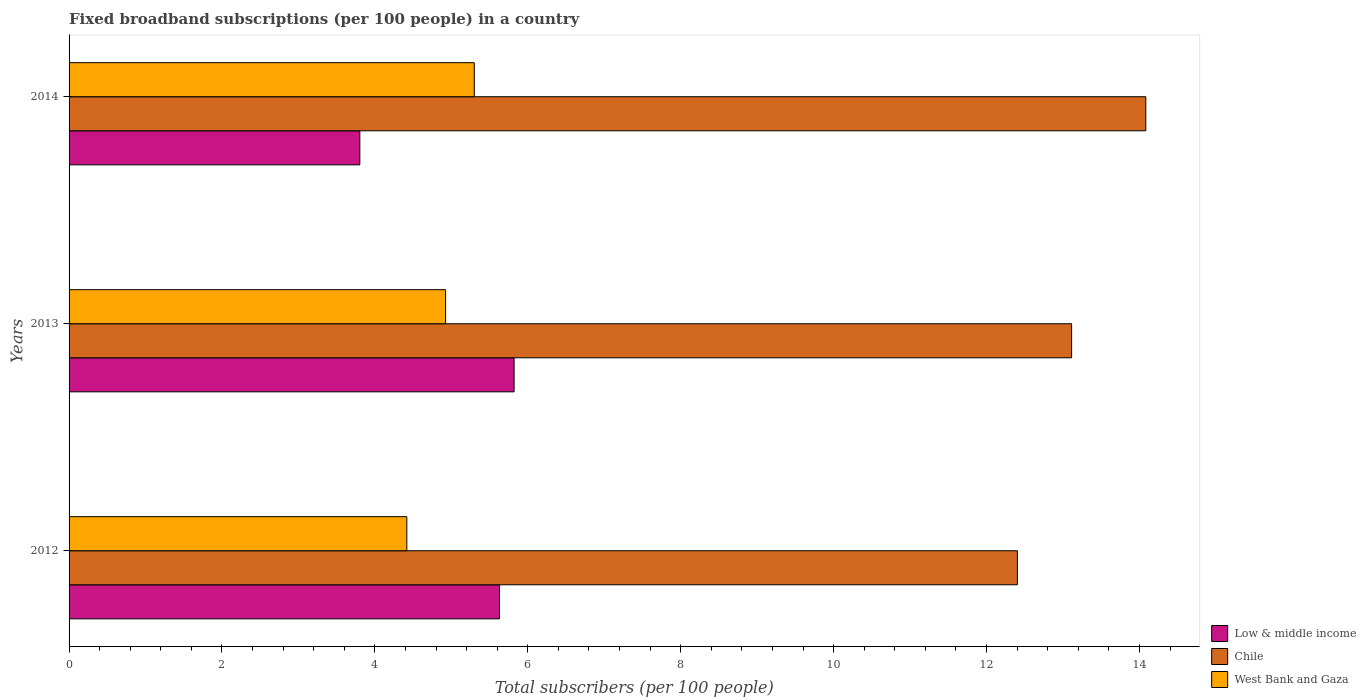How many different coloured bars are there?
Ensure brevity in your answer.  3. How many groups of bars are there?
Keep it short and to the point. 3. Are the number of bars per tick equal to the number of legend labels?
Ensure brevity in your answer.  Yes. How many bars are there on the 1st tick from the top?
Provide a short and direct response. 3. How many bars are there on the 2nd tick from the bottom?
Keep it short and to the point. 3. What is the label of the 1st group of bars from the top?
Your answer should be very brief. 2014. In how many cases, is the number of bars for a given year not equal to the number of legend labels?
Keep it short and to the point. 0. What is the number of broadband subscriptions in Chile in 2012?
Ensure brevity in your answer.  12.4. Across all years, what is the maximum number of broadband subscriptions in Chile?
Provide a short and direct response. 14.08. Across all years, what is the minimum number of broadband subscriptions in Low & middle income?
Ensure brevity in your answer.  3.8. In which year was the number of broadband subscriptions in West Bank and Gaza minimum?
Make the answer very short. 2012. What is the total number of broadband subscriptions in Low & middle income in the graph?
Offer a very short reply. 15.25. What is the difference between the number of broadband subscriptions in Low & middle income in 2012 and that in 2013?
Give a very brief answer. -0.19. What is the difference between the number of broadband subscriptions in Low & middle income in 2014 and the number of broadband subscriptions in Chile in 2013?
Offer a terse response. -9.31. What is the average number of broadband subscriptions in Chile per year?
Offer a terse response. 13.2. In the year 2012, what is the difference between the number of broadband subscriptions in Chile and number of broadband subscriptions in West Bank and Gaza?
Your response must be concise. 7.99. What is the ratio of the number of broadband subscriptions in Low & middle income in 2013 to that in 2014?
Offer a very short reply. 1.53. Is the difference between the number of broadband subscriptions in Chile in 2012 and 2013 greater than the difference between the number of broadband subscriptions in West Bank and Gaza in 2012 and 2013?
Provide a succinct answer. No. What is the difference between the highest and the second highest number of broadband subscriptions in Chile?
Provide a succinct answer. 0.97. What is the difference between the highest and the lowest number of broadband subscriptions in Low & middle income?
Your response must be concise. 2.02. In how many years, is the number of broadband subscriptions in Chile greater than the average number of broadband subscriptions in Chile taken over all years?
Offer a terse response. 1. What does the 2nd bar from the top in 2012 represents?
Your answer should be compact. Chile. What does the 1st bar from the bottom in 2013 represents?
Keep it short and to the point. Low & middle income. What is the difference between two consecutive major ticks on the X-axis?
Make the answer very short. 2. Does the graph contain grids?
Give a very brief answer. No. Where does the legend appear in the graph?
Your response must be concise. Bottom right. How many legend labels are there?
Keep it short and to the point. 3. How are the legend labels stacked?
Your answer should be compact. Vertical. What is the title of the graph?
Keep it short and to the point. Fixed broadband subscriptions (per 100 people) in a country. Does "Upper middle income" appear as one of the legend labels in the graph?
Provide a succinct answer. No. What is the label or title of the X-axis?
Provide a short and direct response. Total subscribers (per 100 people). What is the label or title of the Y-axis?
Offer a very short reply. Years. What is the Total subscribers (per 100 people) in Low & middle income in 2012?
Your answer should be very brief. 5.63. What is the Total subscribers (per 100 people) of Chile in 2012?
Keep it short and to the point. 12.4. What is the Total subscribers (per 100 people) in West Bank and Gaza in 2012?
Offer a terse response. 4.42. What is the Total subscribers (per 100 people) of Low & middle income in 2013?
Provide a short and direct response. 5.82. What is the Total subscribers (per 100 people) in Chile in 2013?
Provide a short and direct response. 13.11. What is the Total subscribers (per 100 people) of West Bank and Gaza in 2013?
Your response must be concise. 4.92. What is the Total subscribers (per 100 people) in Low & middle income in 2014?
Make the answer very short. 3.8. What is the Total subscribers (per 100 people) in Chile in 2014?
Provide a succinct answer. 14.08. What is the Total subscribers (per 100 people) of West Bank and Gaza in 2014?
Give a very brief answer. 5.3. Across all years, what is the maximum Total subscribers (per 100 people) in Low & middle income?
Offer a terse response. 5.82. Across all years, what is the maximum Total subscribers (per 100 people) in Chile?
Offer a very short reply. 14.08. Across all years, what is the maximum Total subscribers (per 100 people) of West Bank and Gaza?
Your answer should be compact. 5.3. Across all years, what is the minimum Total subscribers (per 100 people) in Low & middle income?
Ensure brevity in your answer.  3.8. Across all years, what is the minimum Total subscribers (per 100 people) in Chile?
Provide a short and direct response. 12.4. Across all years, what is the minimum Total subscribers (per 100 people) in West Bank and Gaza?
Your answer should be compact. 4.42. What is the total Total subscribers (per 100 people) of Low & middle income in the graph?
Your response must be concise. 15.25. What is the total Total subscribers (per 100 people) in Chile in the graph?
Offer a terse response. 39.6. What is the total Total subscribers (per 100 people) of West Bank and Gaza in the graph?
Keep it short and to the point. 14.64. What is the difference between the Total subscribers (per 100 people) in Low & middle income in 2012 and that in 2013?
Provide a short and direct response. -0.19. What is the difference between the Total subscribers (per 100 people) in Chile in 2012 and that in 2013?
Provide a short and direct response. -0.71. What is the difference between the Total subscribers (per 100 people) of West Bank and Gaza in 2012 and that in 2013?
Give a very brief answer. -0.51. What is the difference between the Total subscribers (per 100 people) of Low & middle income in 2012 and that in 2014?
Offer a very short reply. 1.83. What is the difference between the Total subscribers (per 100 people) of Chile in 2012 and that in 2014?
Your response must be concise. -1.68. What is the difference between the Total subscribers (per 100 people) of West Bank and Gaza in 2012 and that in 2014?
Provide a succinct answer. -0.88. What is the difference between the Total subscribers (per 100 people) of Low & middle income in 2013 and that in 2014?
Offer a very short reply. 2.02. What is the difference between the Total subscribers (per 100 people) of Chile in 2013 and that in 2014?
Your answer should be compact. -0.97. What is the difference between the Total subscribers (per 100 people) of West Bank and Gaza in 2013 and that in 2014?
Offer a terse response. -0.38. What is the difference between the Total subscribers (per 100 people) of Low & middle income in 2012 and the Total subscribers (per 100 people) of Chile in 2013?
Ensure brevity in your answer.  -7.48. What is the difference between the Total subscribers (per 100 people) in Low & middle income in 2012 and the Total subscribers (per 100 people) in West Bank and Gaza in 2013?
Your answer should be compact. 0.71. What is the difference between the Total subscribers (per 100 people) of Chile in 2012 and the Total subscribers (per 100 people) of West Bank and Gaza in 2013?
Provide a succinct answer. 7.48. What is the difference between the Total subscribers (per 100 people) in Low & middle income in 2012 and the Total subscribers (per 100 people) in Chile in 2014?
Your answer should be very brief. -8.45. What is the difference between the Total subscribers (per 100 people) of Low & middle income in 2012 and the Total subscribers (per 100 people) of West Bank and Gaza in 2014?
Provide a short and direct response. 0.33. What is the difference between the Total subscribers (per 100 people) in Chile in 2012 and the Total subscribers (per 100 people) in West Bank and Gaza in 2014?
Your answer should be compact. 7.1. What is the difference between the Total subscribers (per 100 people) of Low & middle income in 2013 and the Total subscribers (per 100 people) of Chile in 2014?
Offer a very short reply. -8.26. What is the difference between the Total subscribers (per 100 people) in Low & middle income in 2013 and the Total subscribers (per 100 people) in West Bank and Gaza in 2014?
Offer a terse response. 0.52. What is the difference between the Total subscribers (per 100 people) in Chile in 2013 and the Total subscribers (per 100 people) in West Bank and Gaza in 2014?
Provide a short and direct response. 7.81. What is the average Total subscribers (per 100 people) of Low & middle income per year?
Your response must be concise. 5.08. What is the average Total subscribers (per 100 people) of Chile per year?
Your answer should be compact. 13.2. What is the average Total subscribers (per 100 people) of West Bank and Gaza per year?
Ensure brevity in your answer.  4.88. In the year 2012, what is the difference between the Total subscribers (per 100 people) in Low & middle income and Total subscribers (per 100 people) in Chile?
Your response must be concise. -6.77. In the year 2012, what is the difference between the Total subscribers (per 100 people) of Low & middle income and Total subscribers (per 100 people) of West Bank and Gaza?
Your response must be concise. 1.21. In the year 2012, what is the difference between the Total subscribers (per 100 people) in Chile and Total subscribers (per 100 people) in West Bank and Gaza?
Your answer should be very brief. 7.99. In the year 2013, what is the difference between the Total subscribers (per 100 people) in Low & middle income and Total subscribers (per 100 people) in Chile?
Give a very brief answer. -7.29. In the year 2013, what is the difference between the Total subscribers (per 100 people) in Low & middle income and Total subscribers (per 100 people) in West Bank and Gaza?
Give a very brief answer. 0.9. In the year 2013, what is the difference between the Total subscribers (per 100 people) in Chile and Total subscribers (per 100 people) in West Bank and Gaza?
Ensure brevity in your answer.  8.19. In the year 2014, what is the difference between the Total subscribers (per 100 people) of Low & middle income and Total subscribers (per 100 people) of Chile?
Your response must be concise. -10.28. In the year 2014, what is the difference between the Total subscribers (per 100 people) of Low & middle income and Total subscribers (per 100 people) of West Bank and Gaza?
Give a very brief answer. -1.5. In the year 2014, what is the difference between the Total subscribers (per 100 people) in Chile and Total subscribers (per 100 people) in West Bank and Gaza?
Give a very brief answer. 8.78. What is the ratio of the Total subscribers (per 100 people) in Low & middle income in 2012 to that in 2013?
Provide a short and direct response. 0.97. What is the ratio of the Total subscribers (per 100 people) of Chile in 2012 to that in 2013?
Your response must be concise. 0.95. What is the ratio of the Total subscribers (per 100 people) in West Bank and Gaza in 2012 to that in 2013?
Your response must be concise. 0.9. What is the ratio of the Total subscribers (per 100 people) in Low & middle income in 2012 to that in 2014?
Your response must be concise. 1.48. What is the ratio of the Total subscribers (per 100 people) of Chile in 2012 to that in 2014?
Offer a very short reply. 0.88. What is the ratio of the Total subscribers (per 100 people) in West Bank and Gaza in 2012 to that in 2014?
Ensure brevity in your answer.  0.83. What is the ratio of the Total subscribers (per 100 people) of Low & middle income in 2013 to that in 2014?
Ensure brevity in your answer.  1.53. What is the ratio of the Total subscribers (per 100 people) in Chile in 2013 to that in 2014?
Offer a very short reply. 0.93. What is the ratio of the Total subscribers (per 100 people) in West Bank and Gaza in 2013 to that in 2014?
Give a very brief answer. 0.93. What is the difference between the highest and the second highest Total subscribers (per 100 people) in Low & middle income?
Your answer should be compact. 0.19. What is the difference between the highest and the second highest Total subscribers (per 100 people) in Chile?
Offer a terse response. 0.97. What is the difference between the highest and the second highest Total subscribers (per 100 people) in West Bank and Gaza?
Give a very brief answer. 0.38. What is the difference between the highest and the lowest Total subscribers (per 100 people) of Low & middle income?
Provide a succinct answer. 2.02. What is the difference between the highest and the lowest Total subscribers (per 100 people) in Chile?
Provide a short and direct response. 1.68. What is the difference between the highest and the lowest Total subscribers (per 100 people) of West Bank and Gaza?
Offer a very short reply. 0.88. 